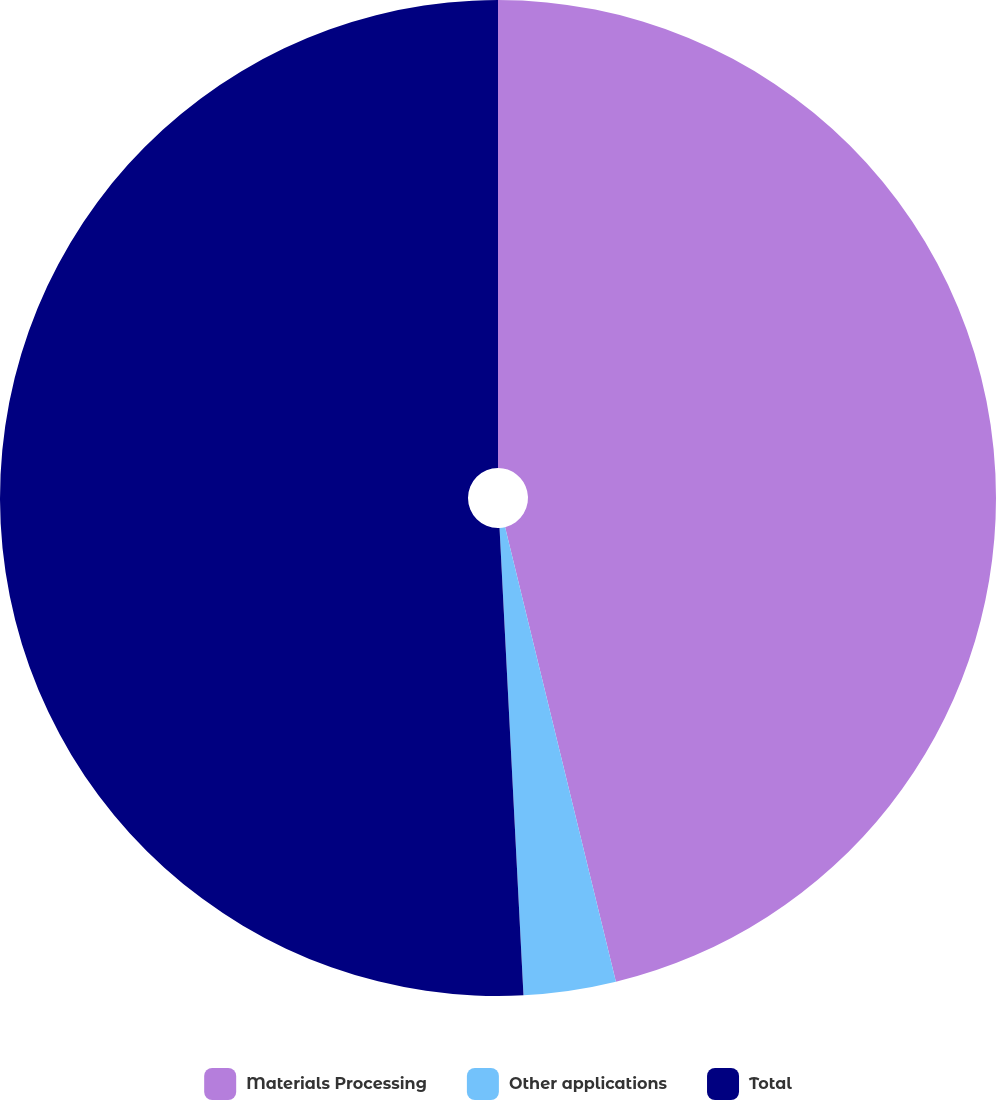<chart> <loc_0><loc_0><loc_500><loc_500><pie_chart><fcel>Materials Processing<fcel>Other applications<fcel>Total<nl><fcel>46.2%<fcel>2.99%<fcel>50.82%<nl></chart> 